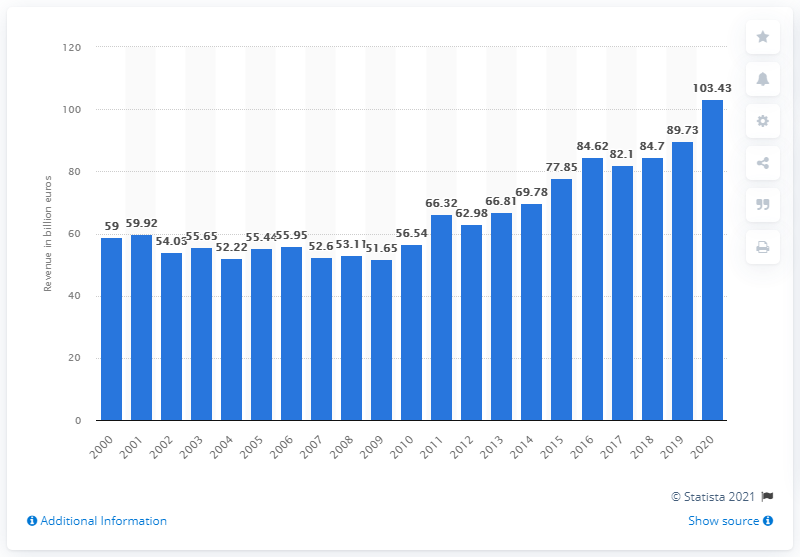Draw attention to some important aspects in this diagram. In 2020, the revenue of the used car market in Germany was 103.43 million units. 